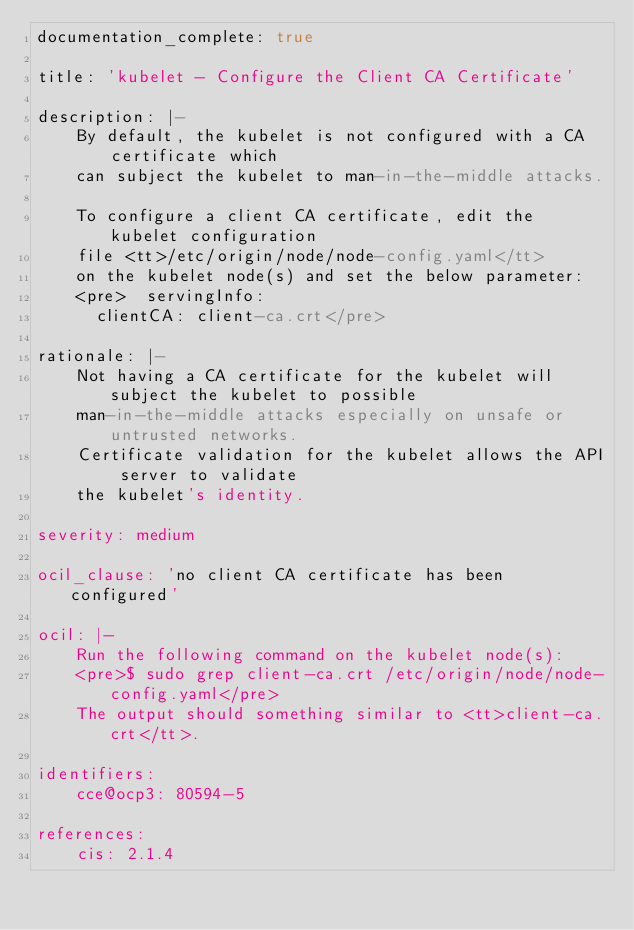<code> <loc_0><loc_0><loc_500><loc_500><_YAML_>documentation_complete: true

title: 'kubelet - Configure the Client CA Certificate'

description: |-
    By default, the kubelet is not configured with a CA certificate which
    can subject the kubelet to man-in-the-middle attacks.

    To configure a client CA certificate, edit the kubelet configuration
    file <tt>/etc/origin/node/node-config.yaml</tt>
    on the kubelet node(s) and set the below parameter:
    <pre>  servingInfo:
      clientCA: client-ca.crt</pre>

rationale: |-
    Not having a CA certificate for the kubelet will subject the kubelet to possible
    man-in-the-middle attacks especially on unsafe or untrusted networks.
    Certificate validation for the kubelet allows the API server to validate
    the kubelet's identity. 

severity: medium

ocil_clause: 'no client CA certificate has been configured'

ocil: |-
    Run the following command on the kubelet node(s):
    <pre>$ sudo grep client-ca.crt /etc/origin/node/node-config.yaml</pre>
    The output should something similar to <tt>client-ca.crt</tt>.

identifiers:
    cce@ocp3: 80594-5

references:
    cis: 2.1.4
</code> 